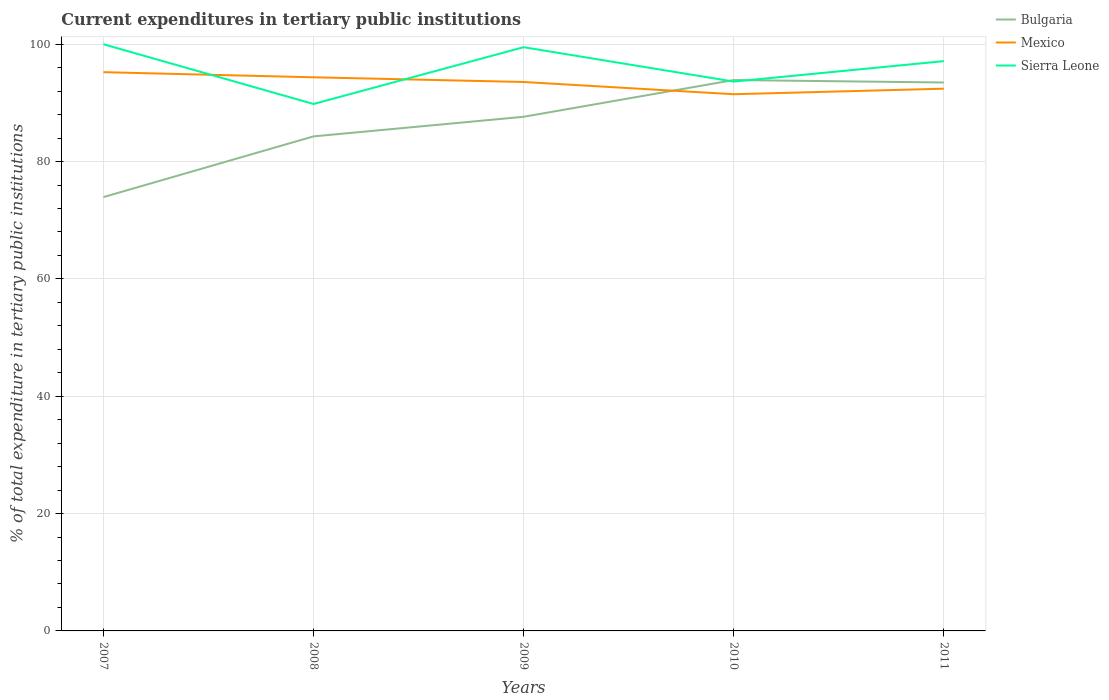Is the number of lines equal to the number of legend labels?
Your answer should be very brief. Yes. Across all years, what is the maximum current expenditures in tertiary public institutions in Mexico?
Provide a succinct answer. 91.48. What is the total current expenditures in tertiary public institutions in Mexico in the graph?
Your answer should be compact. 1.67. What is the difference between the highest and the second highest current expenditures in tertiary public institutions in Sierra Leone?
Provide a short and direct response. 10.19. What is the difference between the highest and the lowest current expenditures in tertiary public institutions in Mexico?
Your response must be concise. 3. How many lines are there?
Your answer should be very brief. 3. How many years are there in the graph?
Your answer should be very brief. 5. What is the difference between two consecutive major ticks on the Y-axis?
Make the answer very short. 20. What is the title of the graph?
Provide a short and direct response. Current expenditures in tertiary public institutions. What is the label or title of the Y-axis?
Give a very brief answer. % of total expenditure in tertiary public institutions. What is the % of total expenditure in tertiary public institutions of Bulgaria in 2007?
Offer a very short reply. 73.94. What is the % of total expenditure in tertiary public institutions of Mexico in 2007?
Your response must be concise. 95.23. What is the % of total expenditure in tertiary public institutions of Bulgaria in 2008?
Your response must be concise. 84.29. What is the % of total expenditure in tertiary public institutions in Mexico in 2008?
Your response must be concise. 94.36. What is the % of total expenditure in tertiary public institutions of Sierra Leone in 2008?
Keep it short and to the point. 89.81. What is the % of total expenditure in tertiary public institutions of Bulgaria in 2009?
Make the answer very short. 87.63. What is the % of total expenditure in tertiary public institutions in Mexico in 2009?
Ensure brevity in your answer.  93.56. What is the % of total expenditure in tertiary public institutions in Sierra Leone in 2009?
Ensure brevity in your answer.  99.49. What is the % of total expenditure in tertiary public institutions of Bulgaria in 2010?
Give a very brief answer. 93.89. What is the % of total expenditure in tertiary public institutions in Mexico in 2010?
Provide a succinct answer. 91.48. What is the % of total expenditure in tertiary public institutions in Sierra Leone in 2010?
Your answer should be very brief. 93.63. What is the % of total expenditure in tertiary public institutions in Bulgaria in 2011?
Ensure brevity in your answer.  93.48. What is the % of total expenditure in tertiary public institutions of Mexico in 2011?
Your answer should be very brief. 92.42. What is the % of total expenditure in tertiary public institutions of Sierra Leone in 2011?
Your response must be concise. 97.12. Across all years, what is the maximum % of total expenditure in tertiary public institutions in Bulgaria?
Offer a terse response. 93.89. Across all years, what is the maximum % of total expenditure in tertiary public institutions in Mexico?
Make the answer very short. 95.23. Across all years, what is the minimum % of total expenditure in tertiary public institutions in Bulgaria?
Ensure brevity in your answer.  73.94. Across all years, what is the minimum % of total expenditure in tertiary public institutions of Mexico?
Give a very brief answer. 91.48. Across all years, what is the minimum % of total expenditure in tertiary public institutions of Sierra Leone?
Provide a short and direct response. 89.81. What is the total % of total expenditure in tertiary public institutions in Bulgaria in the graph?
Ensure brevity in your answer.  433.24. What is the total % of total expenditure in tertiary public institutions of Mexico in the graph?
Your answer should be very brief. 467.06. What is the total % of total expenditure in tertiary public institutions in Sierra Leone in the graph?
Offer a very short reply. 480.05. What is the difference between the % of total expenditure in tertiary public institutions in Bulgaria in 2007 and that in 2008?
Offer a terse response. -10.35. What is the difference between the % of total expenditure in tertiary public institutions of Mexico in 2007 and that in 2008?
Give a very brief answer. 0.87. What is the difference between the % of total expenditure in tertiary public institutions in Sierra Leone in 2007 and that in 2008?
Provide a short and direct response. 10.19. What is the difference between the % of total expenditure in tertiary public institutions of Bulgaria in 2007 and that in 2009?
Your response must be concise. -13.69. What is the difference between the % of total expenditure in tertiary public institutions of Mexico in 2007 and that in 2009?
Your answer should be compact. 1.67. What is the difference between the % of total expenditure in tertiary public institutions of Sierra Leone in 2007 and that in 2009?
Offer a terse response. 0.51. What is the difference between the % of total expenditure in tertiary public institutions in Bulgaria in 2007 and that in 2010?
Your answer should be very brief. -19.95. What is the difference between the % of total expenditure in tertiary public institutions of Mexico in 2007 and that in 2010?
Keep it short and to the point. 3.76. What is the difference between the % of total expenditure in tertiary public institutions in Sierra Leone in 2007 and that in 2010?
Ensure brevity in your answer.  6.37. What is the difference between the % of total expenditure in tertiary public institutions of Bulgaria in 2007 and that in 2011?
Provide a succinct answer. -19.54. What is the difference between the % of total expenditure in tertiary public institutions in Mexico in 2007 and that in 2011?
Your answer should be very brief. 2.81. What is the difference between the % of total expenditure in tertiary public institutions of Sierra Leone in 2007 and that in 2011?
Provide a succinct answer. 2.88. What is the difference between the % of total expenditure in tertiary public institutions in Bulgaria in 2008 and that in 2009?
Provide a short and direct response. -3.34. What is the difference between the % of total expenditure in tertiary public institutions of Mexico in 2008 and that in 2009?
Your answer should be compact. 0.8. What is the difference between the % of total expenditure in tertiary public institutions in Sierra Leone in 2008 and that in 2009?
Provide a short and direct response. -9.68. What is the difference between the % of total expenditure in tertiary public institutions in Bulgaria in 2008 and that in 2010?
Make the answer very short. -9.6. What is the difference between the % of total expenditure in tertiary public institutions in Mexico in 2008 and that in 2010?
Your answer should be compact. 2.89. What is the difference between the % of total expenditure in tertiary public institutions in Sierra Leone in 2008 and that in 2010?
Provide a short and direct response. -3.82. What is the difference between the % of total expenditure in tertiary public institutions in Bulgaria in 2008 and that in 2011?
Your answer should be very brief. -9.19. What is the difference between the % of total expenditure in tertiary public institutions in Mexico in 2008 and that in 2011?
Your response must be concise. 1.94. What is the difference between the % of total expenditure in tertiary public institutions in Sierra Leone in 2008 and that in 2011?
Provide a short and direct response. -7.3. What is the difference between the % of total expenditure in tertiary public institutions of Bulgaria in 2009 and that in 2010?
Your answer should be very brief. -6.26. What is the difference between the % of total expenditure in tertiary public institutions of Mexico in 2009 and that in 2010?
Keep it short and to the point. 2.09. What is the difference between the % of total expenditure in tertiary public institutions in Sierra Leone in 2009 and that in 2010?
Provide a succinct answer. 5.86. What is the difference between the % of total expenditure in tertiary public institutions in Bulgaria in 2009 and that in 2011?
Provide a succinct answer. -5.84. What is the difference between the % of total expenditure in tertiary public institutions in Mexico in 2009 and that in 2011?
Keep it short and to the point. 1.14. What is the difference between the % of total expenditure in tertiary public institutions in Sierra Leone in 2009 and that in 2011?
Offer a terse response. 2.38. What is the difference between the % of total expenditure in tertiary public institutions in Bulgaria in 2010 and that in 2011?
Your answer should be very brief. 0.42. What is the difference between the % of total expenditure in tertiary public institutions of Mexico in 2010 and that in 2011?
Provide a short and direct response. -0.95. What is the difference between the % of total expenditure in tertiary public institutions in Sierra Leone in 2010 and that in 2011?
Your answer should be very brief. -3.49. What is the difference between the % of total expenditure in tertiary public institutions in Bulgaria in 2007 and the % of total expenditure in tertiary public institutions in Mexico in 2008?
Give a very brief answer. -20.42. What is the difference between the % of total expenditure in tertiary public institutions of Bulgaria in 2007 and the % of total expenditure in tertiary public institutions of Sierra Leone in 2008?
Give a very brief answer. -15.87. What is the difference between the % of total expenditure in tertiary public institutions of Mexico in 2007 and the % of total expenditure in tertiary public institutions of Sierra Leone in 2008?
Give a very brief answer. 5.42. What is the difference between the % of total expenditure in tertiary public institutions in Bulgaria in 2007 and the % of total expenditure in tertiary public institutions in Mexico in 2009?
Your answer should be very brief. -19.62. What is the difference between the % of total expenditure in tertiary public institutions in Bulgaria in 2007 and the % of total expenditure in tertiary public institutions in Sierra Leone in 2009?
Your answer should be compact. -25.55. What is the difference between the % of total expenditure in tertiary public institutions of Mexico in 2007 and the % of total expenditure in tertiary public institutions of Sierra Leone in 2009?
Provide a short and direct response. -4.26. What is the difference between the % of total expenditure in tertiary public institutions in Bulgaria in 2007 and the % of total expenditure in tertiary public institutions in Mexico in 2010?
Ensure brevity in your answer.  -17.53. What is the difference between the % of total expenditure in tertiary public institutions of Bulgaria in 2007 and the % of total expenditure in tertiary public institutions of Sierra Leone in 2010?
Your answer should be very brief. -19.69. What is the difference between the % of total expenditure in tertiary public institutions of Mexico in 2007 and the % of total expenditure in tertiary public institutions of Sierra Leone in 2010?
Give a very brief answer. 1.6. What is the difference between the % of total expenditure in tertiary public institutions in Bulgaria in 2007 and the % of total expenditure in tertiary public institutions in Mexico in 2011?
Offer a terse response. -18.48. What is the difference between the % of total expenditure in tertiary public institutions in Bulgaria in 2007 and the % of total expenditure in tertiary public institutions in Sierra Leone in 2011?
Make the answer very short. -23.17. What is the difference between the % of total expenditure in tertiary public institutions of Mexico in 2007 and the % of total expenditure in tertiary public institutions of Sierra Leone in 2011?
Make the answer very short. -1.88. What is the difference between the % of total expenditure in tertiary public institutions of Bulgaria in 2008 and the % of total expenditure in tertiary public institutions of Mexico in 2009?
Ensure brevity in your answer.  -9.27. What is the difference between the % of total expenditure in tertiary public institutions in Bulgaria in 2008 and the % of total expenditure in tertiary public institutions in Sierra Leone in 2009?
Make the answer very short. -15.2. What is the difference between the % of total expenditure in tertiary public institutions in Mexico in 2008 and the % of total expenditure in tertiary public institutions in Sierra Leone in 2009?
Make the answer very short. -5.13. What is the difference between the % of total expenditure in tertiary public institutions of Bulgaria in 2008 and the % of total expenditure in tertiary public institutions of Mexico in 2010?
Your answer should be very brief. -7.18. What is the difference between the % of total expenditure in tertiary public institutions in Bulgaria in 2008 and the % of total expenditure in tertiary public institutions in Sierra Leone in 2010?
Offer a very short reply. -9.34. What is the difference between the % of total expenditure in tertiary public institutions of Mexico in 2008 and the % of total expenditure in tertiary public institutions of Sierra Leone in 2010?
Give a very brief answer. 0.73. What is the difference between the % of total expenditure in tertiary public institutions in Bulgaria in 2008 and the % of total expenditure in tertiary public institutions in Mexico in 2011?
Provide a succinct answer. -8.13. What is the difference between the % of total expenditure in tertiary public institutions of Bulgaria in 2008 and the % of total expenditure in tertiary public institutions of Sierra Leone in 2011?
Make the answer very short. -12.82. What is the difference between the % of total expenditure in tertiary public institutions in Mexico in 2008 and the % of total expenditure in tertiary public institutions in Sierra Leone in 2011?
Your answer should be compact. -2.75. What is the difference between the % of total expenditure in tertiary public institutions in Bulgaria in 2009 and the % of total expenditure in tertiary public institutions in Mexico in 2010?
Ensure brevity in your answer.  -3.84. What is the difference between the % of total expenditure in tertiary public institutions in Bulgaria in 2009 and the % of total expenditure in tertiary public institutions in Sierra Leone in 2010?
Provide a short and direct response. -6. What is the difference between the % of total expenditure in tertiary public institutions in Mexico in 2009 and the % of total expenditure in tertiary public institutions in Sierra Leone in 2010?
Ensure brevity in your answer.  -0.07. What is the difference between the % of total expenditure in tertiary public institutions of Bulgaria in 2009 and the % of total expenditure in tertiary public institutions of Mexico in 2011?
Your answer should be compact. -4.79. What is the difference between the % of total expenditure in tertiary public institutions in Bulgaria in 2009 and the % of total expenditure in tertiary public institutions in Sierra Leone in 2011?
Your response must be concise. -9.48. What is the difference between the % of total expenditure in tertiary public institutions of Mexico in 2009 and the % of total expenditure in tertiary public institutions of Sierra Leone in 2011?
Offer a terse response. -3.55. What is the difference between the % of total expenditure in tertiary public institutions in Bulgaria in 2010 and the % of total expenditure in tertiary public institutions in Mexico in 2011?
Keep it short and to the point. 1.47. What is the difference between the % of total expenditure in tertiary public institutions of Bulgaria in 2010 and the % of total expenditure in tertiary public institutions of Sierra Leone in 2011?
Offer a very short reply. -3.22. What is the difference between the % of total expenditure in tertiary public institutions in Mexico in 2010 and the % of total expenditure in tertiary public institutions in Sierra Leone in 2011?
Offer a terse response. -5.64. What is the average % of total expenditure in tertiary public institutions of Bulgaria per year?
Your answer should be compact. 86.65. What is the average % of total expenditure in tertiary public institutions in Mexico per year?
Give a very brief answer. 93.41. What is the average % of total expenditure in tertiary public institutions in Sierra Leone per year?
Offer a terse response. 96.01. In the year 2007, what is the difference between the % of total expenditure in tertiary public institutions of Bulgaria and % of total expenditure in tertiary public institutions of Mexico?
Your response must be concise. -21.29. In the year 2007, what is the difference between the % of total expenditure in tertiary public institutions in Bulgaria and % of total expenditure in tertiary public institutions in Sierra Leone?
Your answer should be compact. -26.06. In the year 2007, what is the difference between the % of total expenditure in tertiary public institutions of Mexico and % of total expenditure in tertiary public institutions of Sierra Leone?
Your answer should be compact. -4.77. In the year 2008, what is the difference between the % of total expenditure in tertiary public institutions in Bulgaria and % of total expenditure in tertiary public institutions in Mexico?
Provide a succinct answer. -10.07. In the year 2008, what is the difference between the % of total expenditure in tertiary public institutions in Bulgaria and % of total expenditure in tertiary public institutions in Sierra Leone?
Your response must be concise. -5.52. In the year 2008, what is the difference between the % of total expenditure in tertiary public institutions in Mexico and % of total expenditure in tertiary public institutions in Sierra Leone?
Your answer should be compact. 4.55. In the year 2009, what is the difference between the % of total expenditure in tertiary public institutions of Bulgaria and % of total expenditure in tertiary public institutions of Mexico?
Provide a short and direct response. -5.93. In the year 2009, what is the difference between the % of total expenditure in tertiary public institutions in Bulgaria and % of total expenditure in tertiary public institutions in Sierra Leone?
Keep it short and to the point. -11.86. In the year 2009, what is the difference between the % of total expenditure in tertiary public institutions in Mexico and % of total expenditure in tertiary public institutions in Sierra Leone?
Ensure brevity in your answer.  -5.93. In the year 2010, what is the difference between the % of total expenditure in tertiary public institutions of Bulgaria and % of total expenditure in tertiary public institutions of Mexico?
Your response must be concise. 2.42. In the year 2010, what is the difference between the % of total expenditure in tertiary public institutions of Bulgaria and % of total expenditure in tertiary public institutions of Sierra Leone?
Ensure brevity in your answer.  0.26. In the year 2010, what is the difference between the % of total expenditure in tertiary public institutions of Mexico and % of total expenditure in tertiary public institutions of Sierra Leone?
Your answer should be compact. -2.15. In the year 2011, what is the difference between the % of total expenditure in tertiary public institutions in Bulgaria and % of total expenditure in tertiary public institutions in Mexico?
Offer a very short reply. 1.06. In the year 2011, what is the difference between the % of total expenditure in tertiary public institutions of Bulgaria and % of total expenditure in tertiary public institutions of Sierra Leone?
Your answer should be compact. -3.64. In the year 2011, what is the difference between the % of total expenditure in tertiary public institutions of Mexico and % of total expenditure in tertiary public institutions of Sierra Leone?
Your answer should be very brief. -4.69. What is the ratio of the % of total expenditure in tertiary public institutions of Bulgaria in 2007 to that in 2008?
Ensure brevity in your answer.  0.88. What is the ratio of the % of total expenditure in tertiary public institutions of Mexico in 2007 to that in 2008?
Make the answer very short. 1.01. What is the ratio of the % of total expenditure in tertiary public institutions in Sierra Leone in 2007 to that in 2008?
Ensure brevity in your answer.  1.11. What is the ratio of the % of total expenditure in tertiary public institutions in Bulgaria in 2007 to that in 2009?
Offer a very short reply. 0.84. What is the ratio of the % of total expenditure in tertiary public institutions of Mexico in 2007 to that in 2009?
Offer a very short reply. 1.02. What is the ratio of the % of total expenditure in tertiary public institutions in Bulgaria in 2007 to that in 2010?
Your response must be concise. 0.79. What is the ratio of the % of total expenditure in tertiary public institutions in Mexico in 2007 to that in 2010?
Your response must be concise. 1.04. What is the ratio of the % of total expenditure in tertiary public institutions of Sierra Leone in 2007 to that in 2010?
Provide a succinct answer. 1.07. What is the ratio of the % of total expenditure in tertiary public institutions of Bulgaria in 2007 to that in 2011?
Your response must be concise. 0.79. What is the ratio of the % of total expenditure in tertiary public institutions in Mexico in 2007 to that in 2011?
Keep it short and to the point. 1.03. What is the ratio of the % of total expenditure in tertiary public institutions in Sierra Leone in 2007 to that in 2011?
Your answer should be compact. 1.03. What is the ratio of the % of total expenditure in tertiary public institutions of Bulgaria in 2008 to that in 2009?
Your response must be concise. 0.96. What is the ratio of the % of total expenditure in tertiary public institutions in Mexico in 2008 to that in 2009?
Your answer should be compact. 1.01. What is the ratio of the % of total expenditure in tertiary public institutions of Sierra Leone in 2008 to that in 2009?
Your response must be concise. 0.9. What is the ratio of the % of total expenditure in tertiary public institutions of Bulgaria in 2008 to that in 2010?
Offer a very short reply. 0.9. What is the ratio of the % of total expenditure in tertiary public institutions of Mexico in 2008 to that in 2010?
Provide a short and direct response. 1.03. What is the ratio of the % of total expenditure in tertiary public institutions of Sierra Leone in 2008 to that in 2010?
Keep it short and to the point. 0.96. What is the ratio of the % of total expenditure in tertiary public institutions of Bulgaria in 2008 to that in 2011?
Your answer should be compact. 0.9. What is the ratio of the % of total expenditure in tertiary public institutions in Mexico in 2008 to that in 2011?
Your response must be concise. 1.02. What is the ratio of the % of total expenditure in tertiary public institutions in Sierra Leone in 2008 to that in 2011?
Give a very brief answer. 0.92. What is the ratio of the % of total expenditure in tertiary public institutions of Bulgaria in 2009 to that in 2010?
Give a very brief answer. 0.93. What is the ratio of the % of total expenditure in tertiary public institutions of Mexico in 2009 to that in 2010?
Offer a very short reply. 1.02. What is the ratio of the % of total expenditure in tertiary public institutions in Sierra Leone in 2009 to that in 2010?
Make the answer very short. 1.06. What is the ratio of the % of total expenditure in tertiary public institutions of Bulgaria in 2009 to that in 2011?
Keep it short and to the point. 0.94. What is the ratio of the % of total expenditure in tertiary public institutions in Mexico in 2009 to that in 2011?
Offer a terse response. 1.01. What is the ratio of the % of total expenditure in tertiary public institutions of Sierra Leone in 2009 to that in 2011?
Your answer should be compact. 1.02. What is the ratio of the % of total expenditure in tertiary public institutions of Mexico in 2010 to that in 2011?
Your response must be concise. 0.99. What is the ratio of the % of total expenditure in tertiary public institutions of Sierra Leone in 2010 to that in 2011?
Give a very brief answer. 0.96. What is the difference between the highest and the second highest % of total expenditure in tertiary public institutions of Bulgaria?
Offer a very short reply. 0.42. What is the difference between the highest and the second highest % of total expenditure in tertiary public institutions in Mexico?
Provide a succinct answer. 0.87. What is the difference between the highest and the second highest % of total expenditure in tertiary public institutions in Sierra Leone?
Your response must be concise. 0.51. What is the difference between the highest and the lowest % of total expenditure in tertiary public institutions in Bulgaria?
Offer a very short reply. 19.95. What is the difference between the highest and the lowest % of total expenditure in tertiary public institutions of Mexico?
Your response must be concise. 3.76. What is the difference between the highest and the lowest % of total expenditure in tertiary public institutions in Sierra Leone?
Keep it short and to the point. 10.19. 